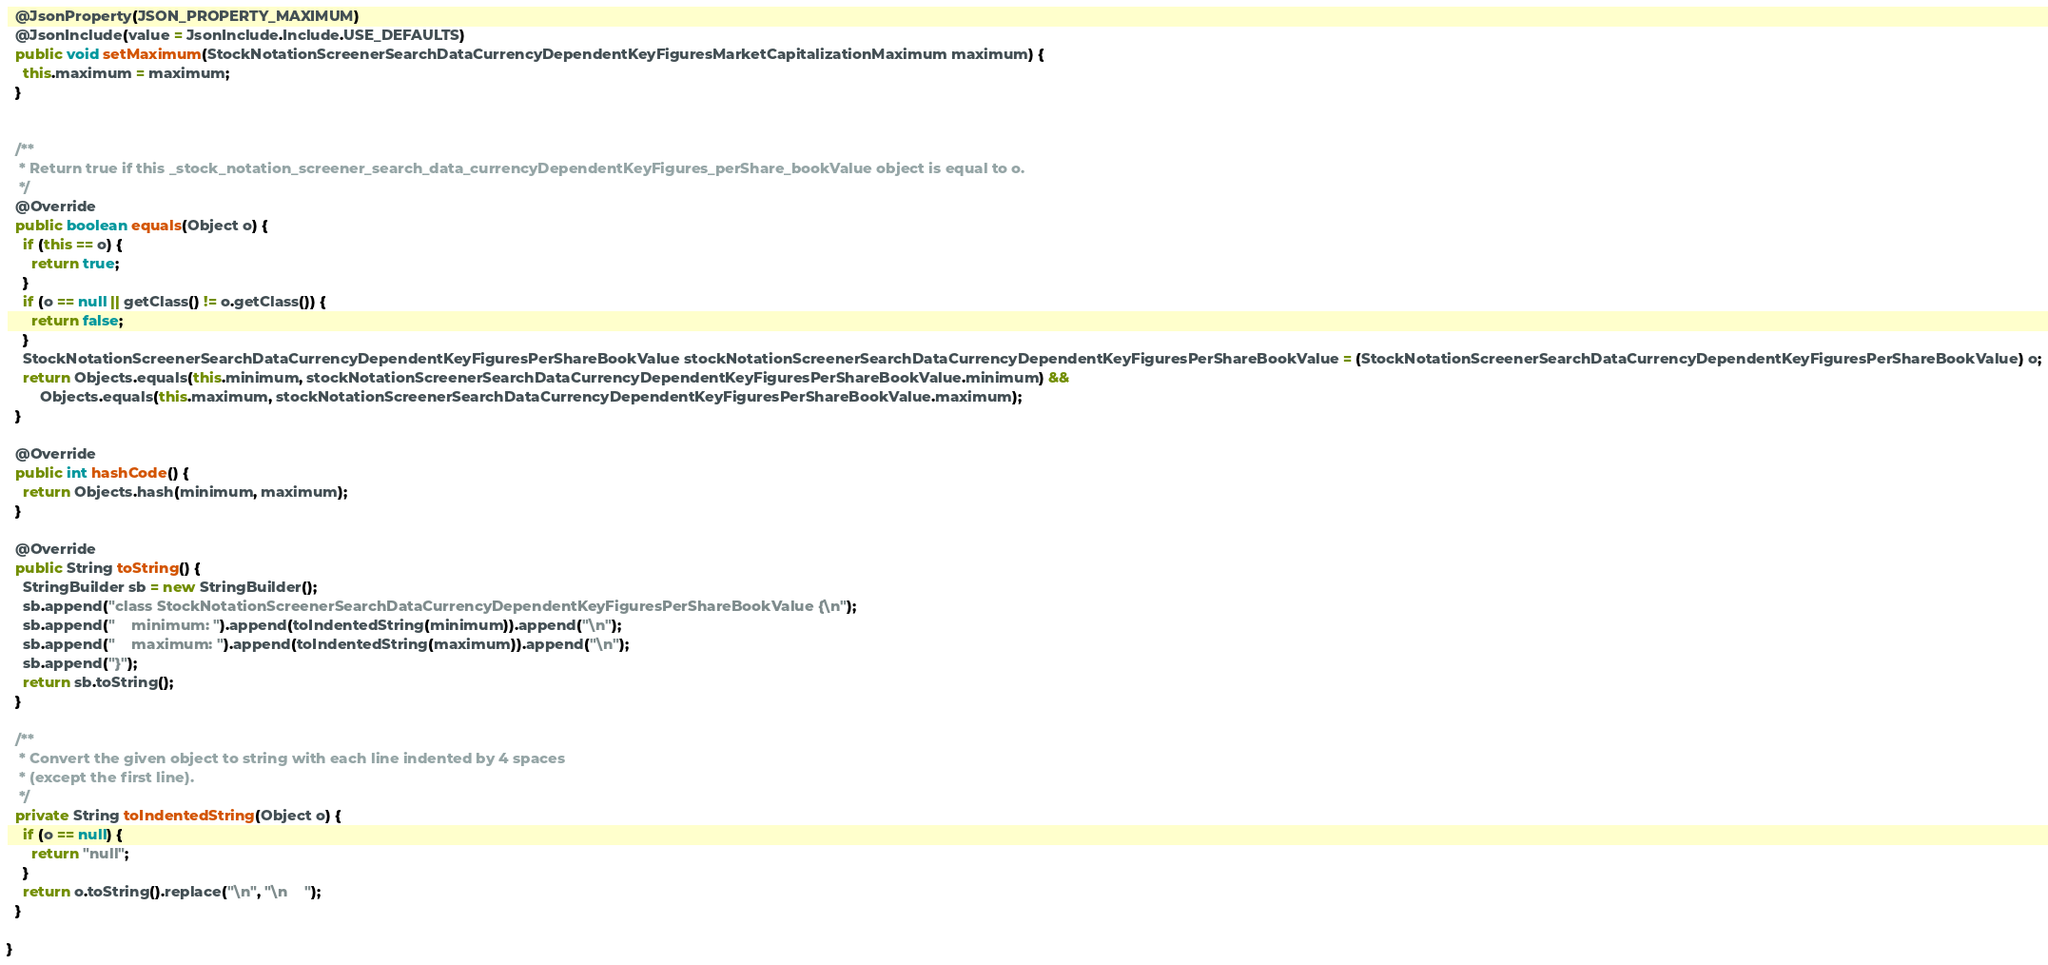<code> <loc_0><loc_0><loc_500><loc_500><_Java_>
  @JsonProperty(JSON_PROPERTY_MAXIMUM)
  @JsonInclude(value = JsonInclude.Include.USE_DEFAULTS)
  public void setMaximum(StockNotationScreenerSearchDataCurrencyDependentKeyFiguresMarketCapitalizationMaximum maximum) {
    this.maximum = maximum;
  }


  /**
   * Return true if this _stock_notation_screener_search_data_currencyDependentKeyFigures_perShare_bookValue object is equal to o.
   */
  @Override
  public boolean equals(Object o) {
    if (this == o) {
      return true;
    }
    if (o == null || getClass() != o.getClass()) {
      return false;
    }
    StockNotationScreenerSearchDataCurrencyDependentKeyFiguresPerShareBookValue stockNotationScreenerSearchDataCurrencyDependentKeyFiguresPerShareBookValue = (StockNotationScreenerSearchDataCurrencyDependentKeyFiguresPerShareBookValue) o;
    return Objects.equals(this.minimum, stockNotationScreenerSearchDataCurrencyDependentKeyFiguresPerShareBookValue.minimum) &&
        Objects.equals(this.maximum, stockNotationScreenerSearchDataCurrencyDependentKeyFiguresPerShareBookValue.maximum);
  }

  @Override
  public int hashCode() {
    return Objects.hash(minimum, maximum);
  }

  @Override
  public String toString() {
    StringBuilder sb = new StringBuilder();
    sb.append("class StockNotationScreenerSearchDataCurrencyDependentKeyFiguresPerShareBookValue {\n");
    sb.append("    minimum: ").append(toIndentedString(minimum)).append("\n");
    sb.append("    maximum: ").append(toIndentedString(maximum)).append("\n");
    sb.append("}");
    return sb.toString();
  }

  /**
   * Convert the given object to string with each line indented by 4 spaces
   * (except the first line).
   */
  private String toIndentedString(Object o) {
    if (o == null) {
      return "null";
    }
    return o.toString().replace("\n", "\n    ");
  }

}

</code> 